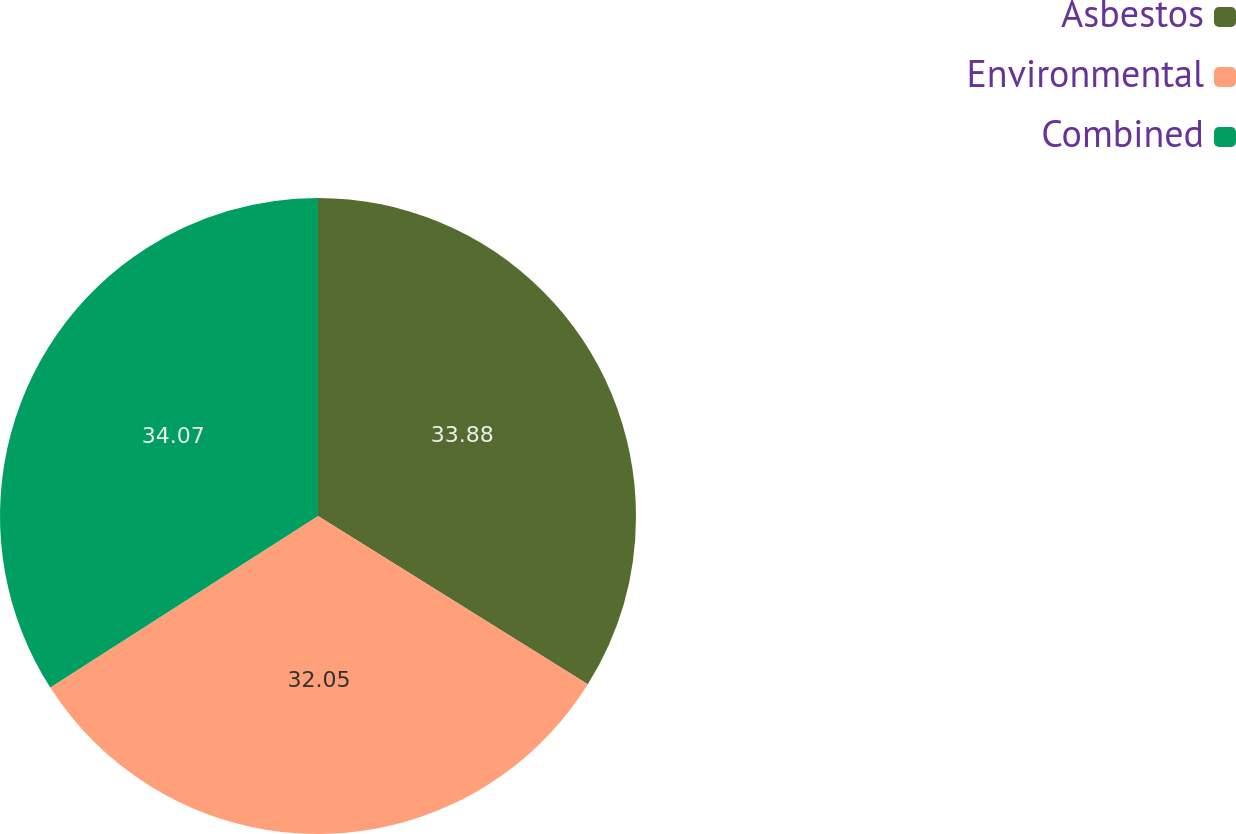<chart> <loc_0><loc_0><loc_500><loc_500><pie_chart><fcel>Asbestos<fcel>Environmental<fcel>Combined<nl><fcel>33.88%<fcel>32.05%<fcel>34.07%<nl></chart> 